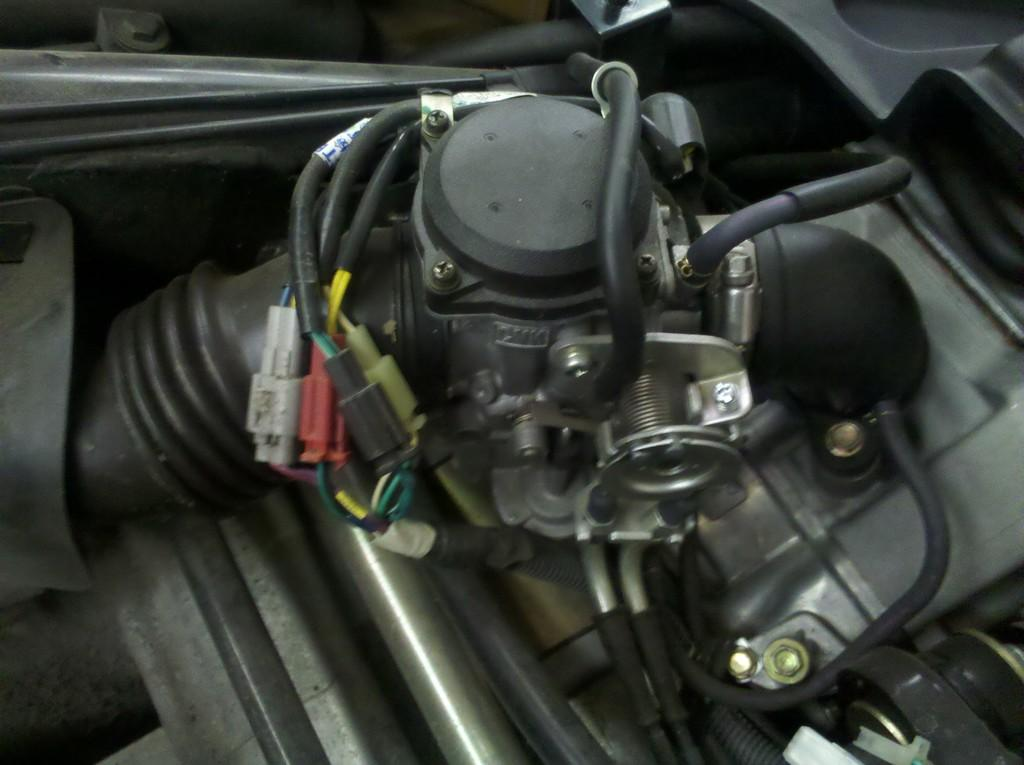What is the main subject of the image? The main subject of the image is the engine of a car. Can you describe the engine in the image? The engine appears to be a complex system of parts and components. What type of vehicle does the engine belong to? The specific type of vehicle cannot be determined from the image alone. What shape is the skate in the image? There is no skate present in the image; it features the engine of a car. 